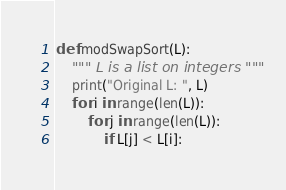Convert code to text. <code><loc_0><loc_0><loc_500><loc_500><_Python_>def modSwapSort(L):
    """ L is a list on integers """
    print("Original L: ", L)
    for i in range(len(L)):
        for j in range(len(L)):
            if L[j] < L[i]:</code> 